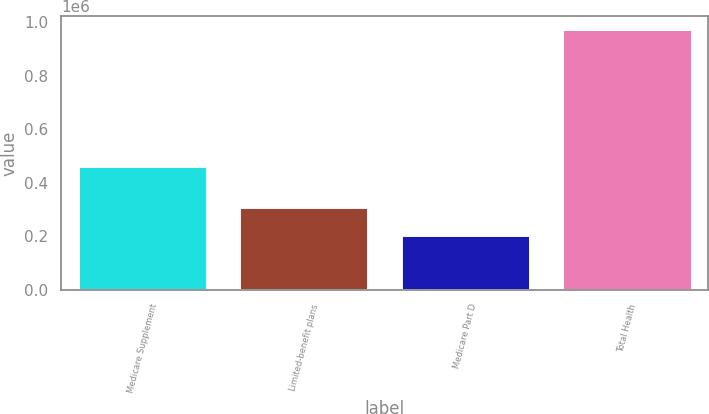Convert chart. <chart><loc_0><loc_0><loc_500><loc_500><bar_chart><fcel>Medicare Supplement<fcel>Limited-benefit plans<fcel>Medicare Part D<fcel>Total Health<nl><fcel>461386<fcel>308899<fcel>203340<fcel>973625<nl></chart> 